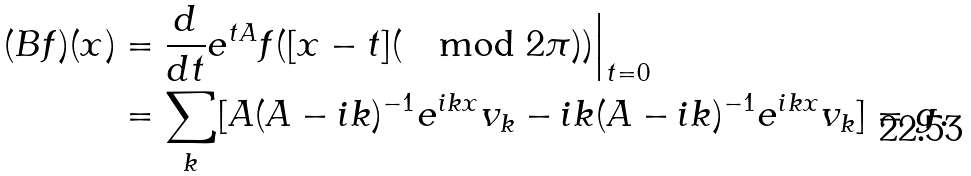Convert formula to latex. <formula><loc_0><loc_0><loc_500><loc_500>( B f ) ( x ) & = \frac { d } { d t } e ^ { t A } f ( [ x - t ] ( \mod 2 \pi ) ) \Big | _ { t = 0 } \\ & = \sum _ { k } [ A ( A - i k ) ^ { - 1 } e ^ { i k x } v _ { k } - i k ( A - i k ) ^ { - 1 } e ^ { i k x } v _ { k } ] = g .</formula> 